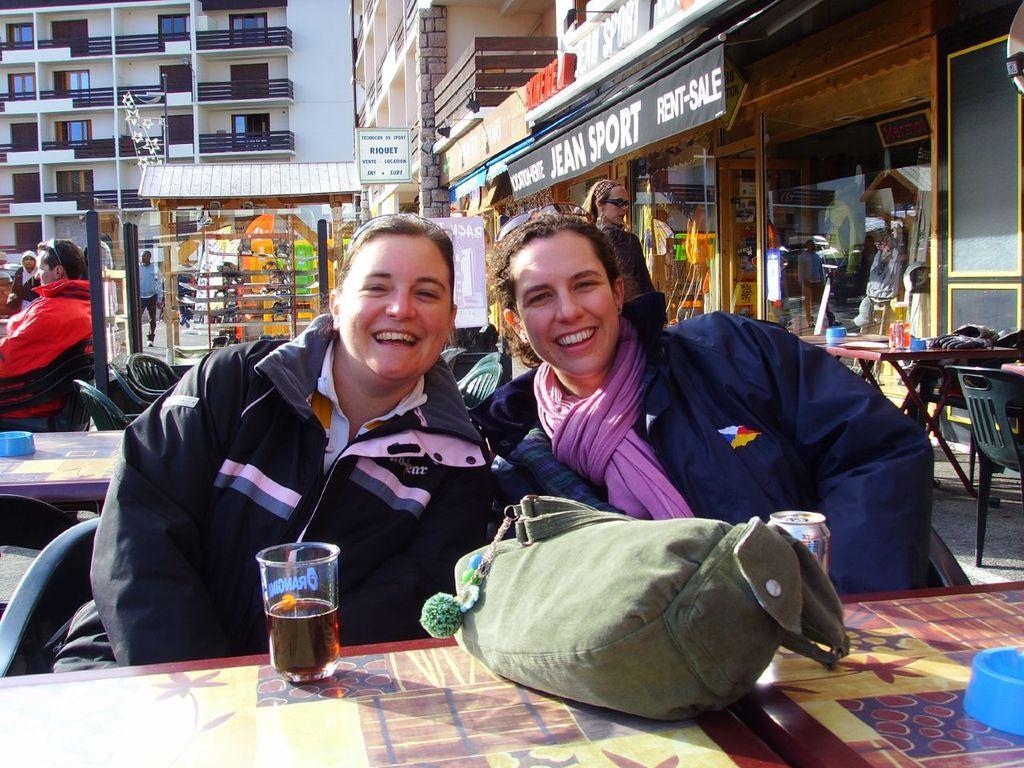In one or two sentences, can you explain what this image depicts? There are two women sitting at the table. On the table there is a glass,tin and a bag. In the background there are buildings,tables,chair,glass doors and few people. 